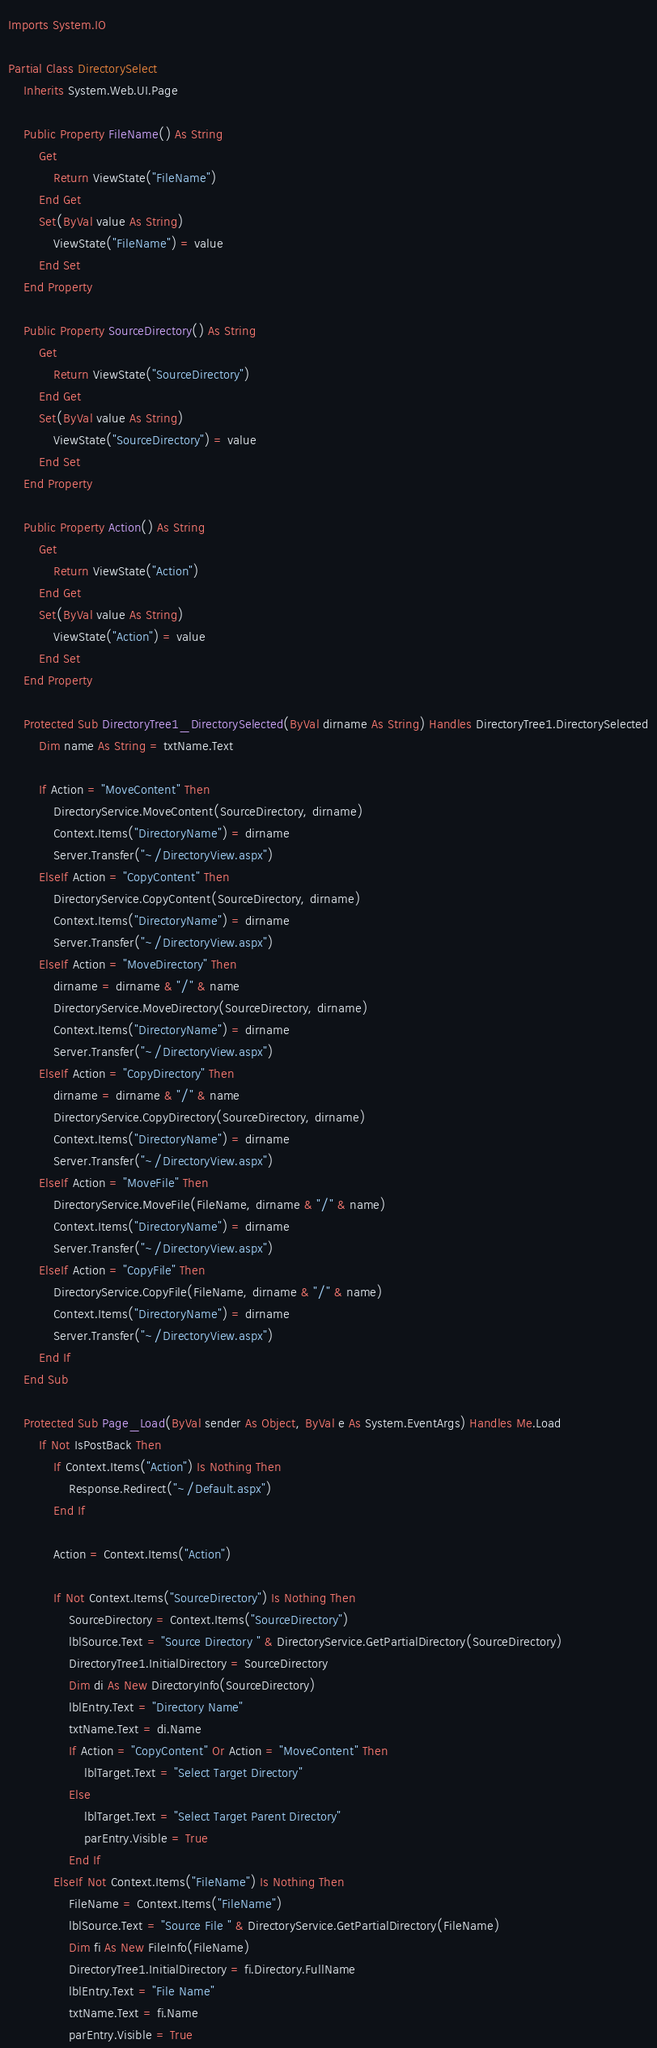<code> <loc_0><loc_0><loc_500><loc_500><_VisualBasic_>
Imports System.IO

Partial Class DirectorySelect
    Inherits System.Web.UI.Page

    Public Property FileName() As String
        Get
            Return ViewState("FileName")
        End Get
        Set(ByVal value As String)
            ViewState("FileName") = value
        End Set
    End Property

    Public Property SourceDirectory() As String
        Get
            Return ViewState("SourceDirectory")
        End Get
        Set(ByVal value As String)
            ViewState("SourceDirectory") = value
        End Set
    End Property

    Public Property Action() As String
        Get
            Return ViewState("Action")
        End Get
        Set(ByVal value As String)
            ViewState("Action") = value
        End Set
    End Property

    Protected Sub DirectoryTree1_DirectorySelected(ByVal dirname As String) Handles DirectoryTree1.DirectorySelected
        Dim name As String = txtName.Text

        If Action = "MoveContent" Then
            DirectoryService.MoveContent(SourceDirectory, dirname)
            Context.Items("DirectoryName") = dirname
            Server.Transfer("~/DirectoryView.aspx")
        ElseIf Action = "CopyContent" Then
            DirectoryService.CopyContent(SourceDirectory, dirname)
            Context.Items("DirectoryName") = dirname
            Server.Transfer("~/DirectoryView.aspx")
        ElseIf Action = "MoveDirectory" Then
            dirname = dirname & "/" & name
            DirectoryService.MoveDirectory(SourceDirectory, dirname)
            Context.Items("DirectoryName") = dirname
            Server.Transfer("~/DirectoryView.aspx")
        ElseIf Action = "CopyDirectory" Then
            dirname = dirname & "/" & name
            DirectoryService.CopyDirectory(SourceDirectory, dirname)
            Context.Items("DirectoryName") = dirname
            Server.Transfer("~/DirectoryView.aspx")
        ElseIf Action = "MoveFile" Then
            DirectoryService.MoveFile(FileName, dirname & "/" & name)
            Context.Items("DirectoryName") = dirname
            Server.Transfer("~/DirectoryView.aspx")
        ElseIf Action = "CopyFile" Then
            DirectoryService.CopyFile(FileName, dirname & "/" & name)
            Context.Items("DirectoryName") = dirname
            Server.Transfer("~/DirectoryView.aspx")
        End If
    End Sub

    Protected Sub Page_Load(ByVal sender As Object, ByVal e As System.EventArgs) Handles Me.Load
        If Not IsPostBack Then
            If Context.Items("Action") Is Nothing Then
                Response.Redirect("~/Default.aspx")
            End If

            Action = Context.Items("Action")

            If Not Context.Items("SourceDirectory") Is Nothing Then
                SourceDirectory = Context.Items("SourceDirectory")
                lblSource.Text = "Source Directory " & DirectoryService.GetPartialDirectory(SourceDirectory)
                DirectoryTree1.InitialDirectory = SourceDirectory
                Dim di As New DirectoryInfo(SourceDirectory)
                lblEntry.Text = "Directory Name"
                txtName.Text = di.Name
                If Action = "CopyContent" Or Action = "MoveContent" Then
                    lblTarget.Text = "Select Target Directory"
                Else
                    lblTarget.Text = "Select Target Parent Directory"
                    parEntry.Visible = True
                End If
            ElseIf Not Context.Items("FileName") Is Nothing Then
                FileName = Context.Items("FileName")
                lblSource.Text = "Source File " & DirectoryService.GetPartialDirectory(FileName)
                Dim fi As New FileInfo(FileName)
                DirectoryTree1.InitialDirectory = fi.Directory.FullName
                lblEntry.Text = "File Name"
                txtName.Text = fi.Name
                parEntry.Visible = True</code> 